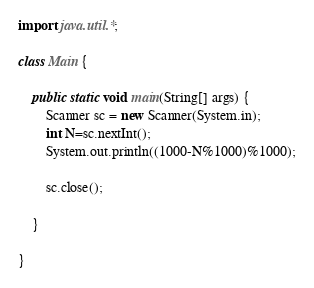Convert code to text. <code><loc_0><loc_0><loc_500><loc_500><_Java_>import java.util.*;

class Main {

	public static void main(String[] args) {
		Scanner sc = new Scanner(System.in);
		int N=sc.nextInt();
		System.out.println((1000-N%1000)%1000);
		
		sc.close();

	}

}</code> 